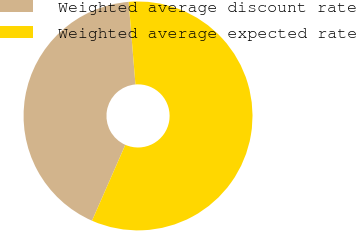<chart> <loc_0><loc_0><loc_500><loc_500><pie_chart><fcel>Weighted average discount rate<fcel>Weighted average expected rate<nl><fcel>42.11%<fcel>57.89%<nl></chart> 